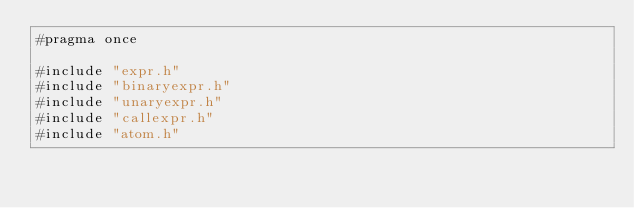<code> <loc_0><loc_0><loc_500><loc_500><_C_>#pragma once

#include "expr.h"
#include "binaryexpr.h"
#include "unaryexpr.h"
#include "callexpr.h"
#include "atom.h"
</code> 